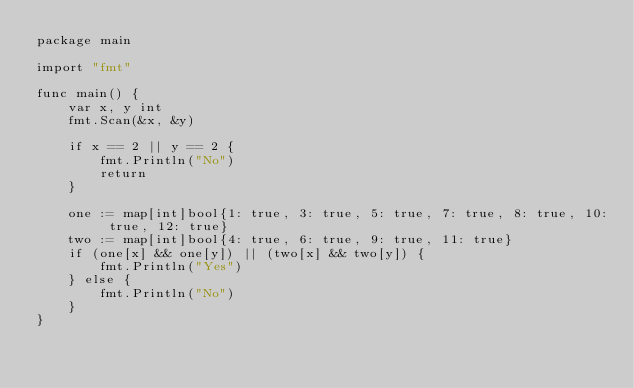Convert code to text. <code><loc_0><loc_0><loc_500><loc_500><_Go_>package main

import "fmt"

func main() {
	var x, y int
	fmt.Scan(&x, &y)

	if x == 2 || y == 2 {
		fmt.Println("No")
		return
	}

	one := map[int]bool{1: true, 3: true, 5: true, 7: true, 8: true, 10: true, 12: true}
	two := map[int]bool{4: true, 6: true, 9: true, 11: true}
	if (one[x] && one[y]) || (two[x] && two[y]) {
		fmt.Println("Yes")
	} else {
		fmt.Println("No")
	}
}
</code> 